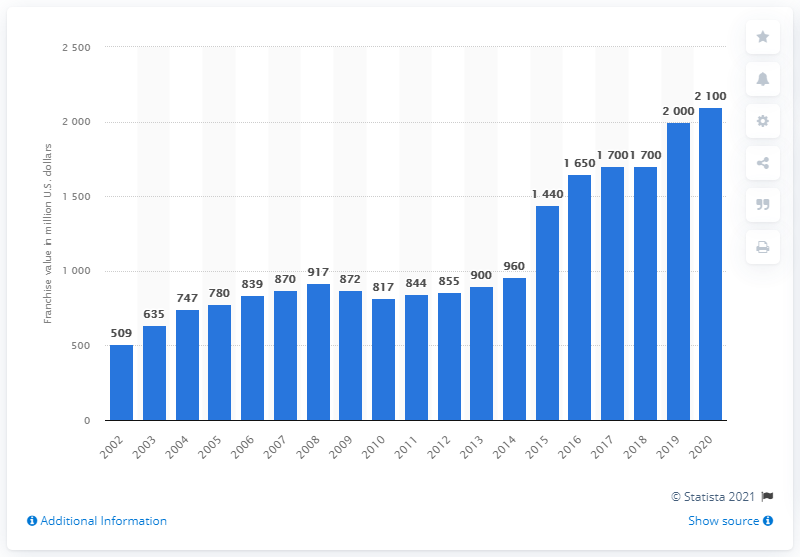Point out several critical features in this image. In the year 2020, the franchise value of the Detroit Lions was estimated to be approximately 2100. 